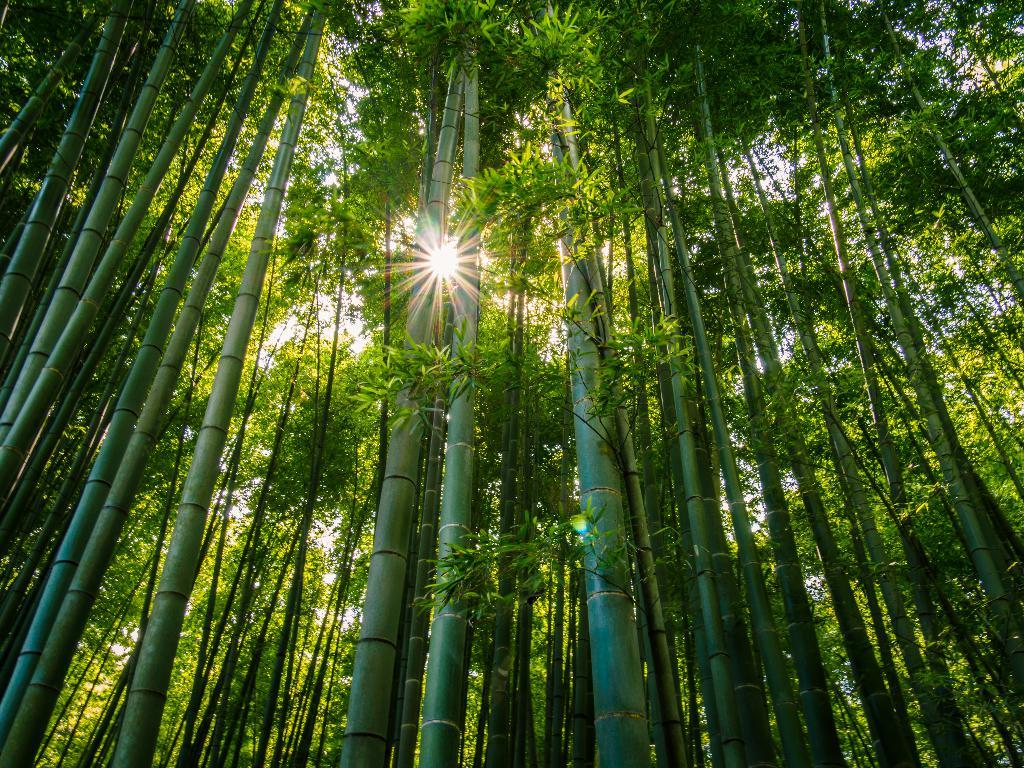What type of trees can be seen in the image? There are bamboo trees in the image. What celestial body is visible in the image? The sun is visible in the image. What else can be seen in the sky besides the sun? The sky is visible in the image, but no other celestial bodies or objects are mentioned. What type of bun is being used as a hobby in the image? There is no bun or hobby mentioned in the image; it features bamboo trees, the sun, and the sky. 